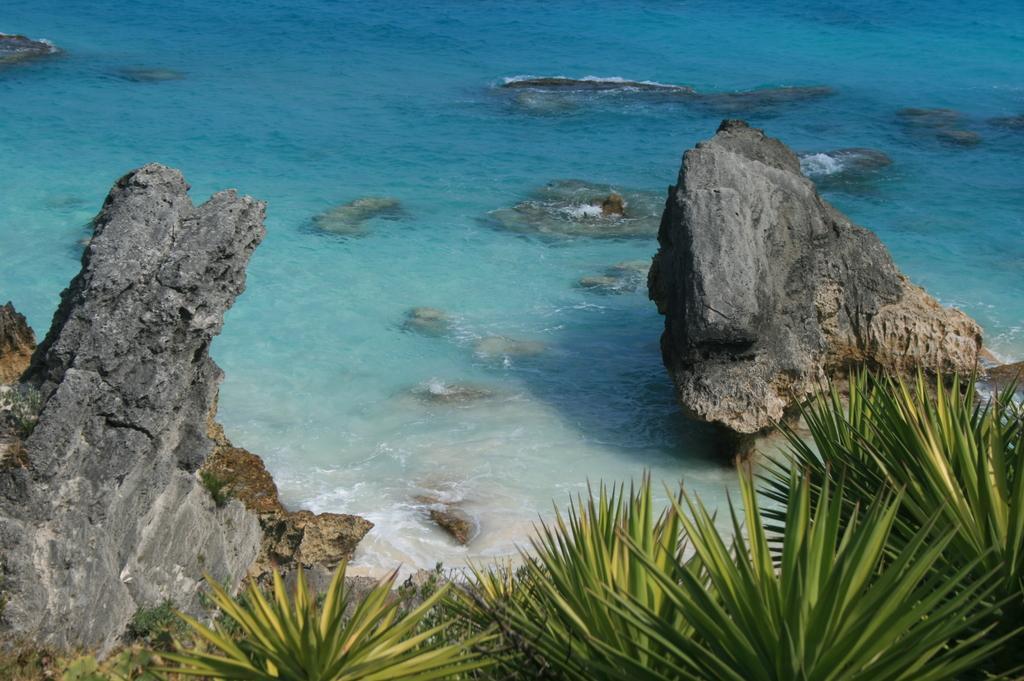Please provide a concise description of this image. In this image in the front there are plants. In the center there are stones and in the background there is water. 